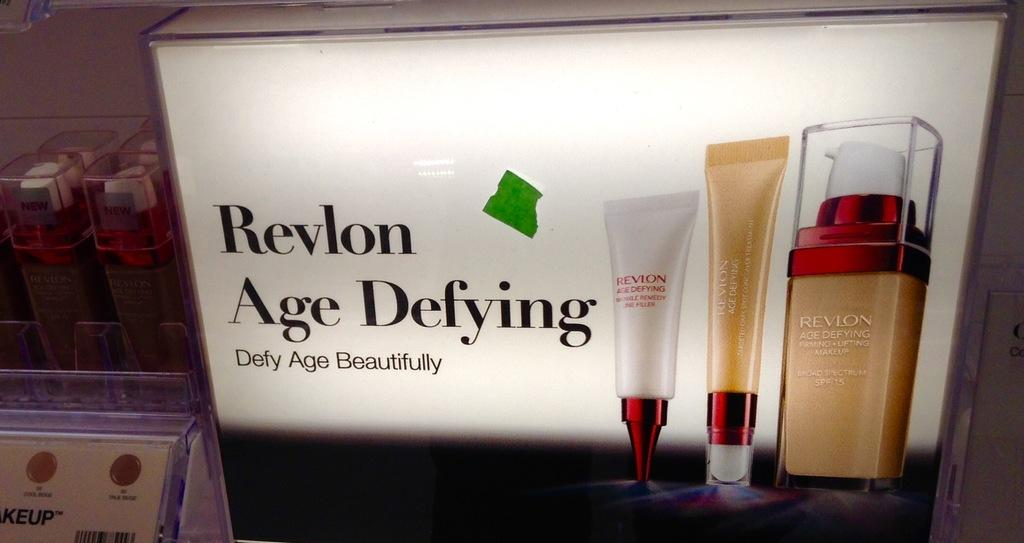<image>
Render a clear and concise summary of the photo. Revlon likes to brand itself as an age defying product. 